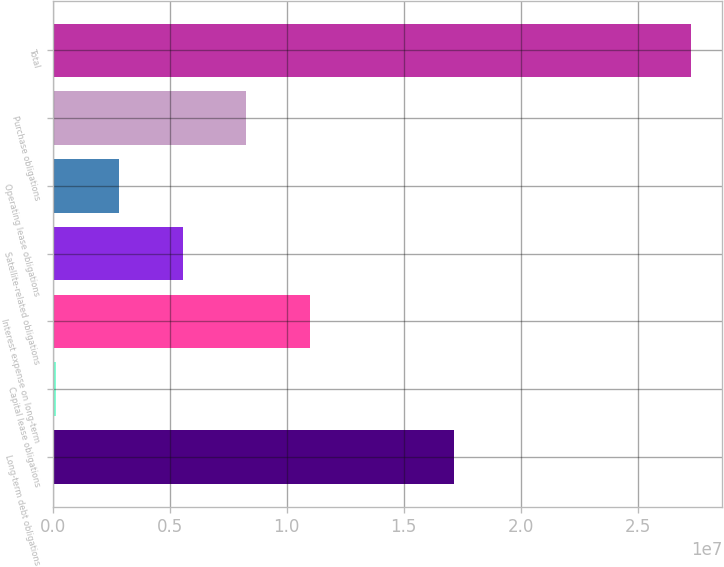<chart> <loc_0><loc_0><loc_500><loc_500><bar_chart><fcel>Long-term debt obligations<fcel>Capital lease obligations<fcel>Interest expense on long-term<fcel>Satellite-related obligations<fcel>Operating lease obligations<fcel>Purchase obligations<fcel>Total<nl><fcel>1.71478e+07<fcel>136146<fcel>1.09838e+07<fcel>5.55998e+06<fcel>2.84806e+06<fcel>8.2719e+06<fcel>2.72553e+07<nl></chart> 